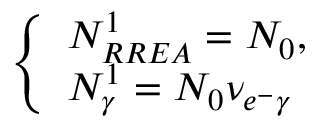Convert formula to latex. <formula><loc_0><loc_0><loc_500><loc_500>\left \{ \begin{array} { l l } { N _ { R R E A } ^ { 1 } = N _ { 0 } , } \\ { N _ { \gamma } ^ { 1 } = N _ { 0 } \nu _ { e ^ { - } \gamma } } \end{array}</formula> 